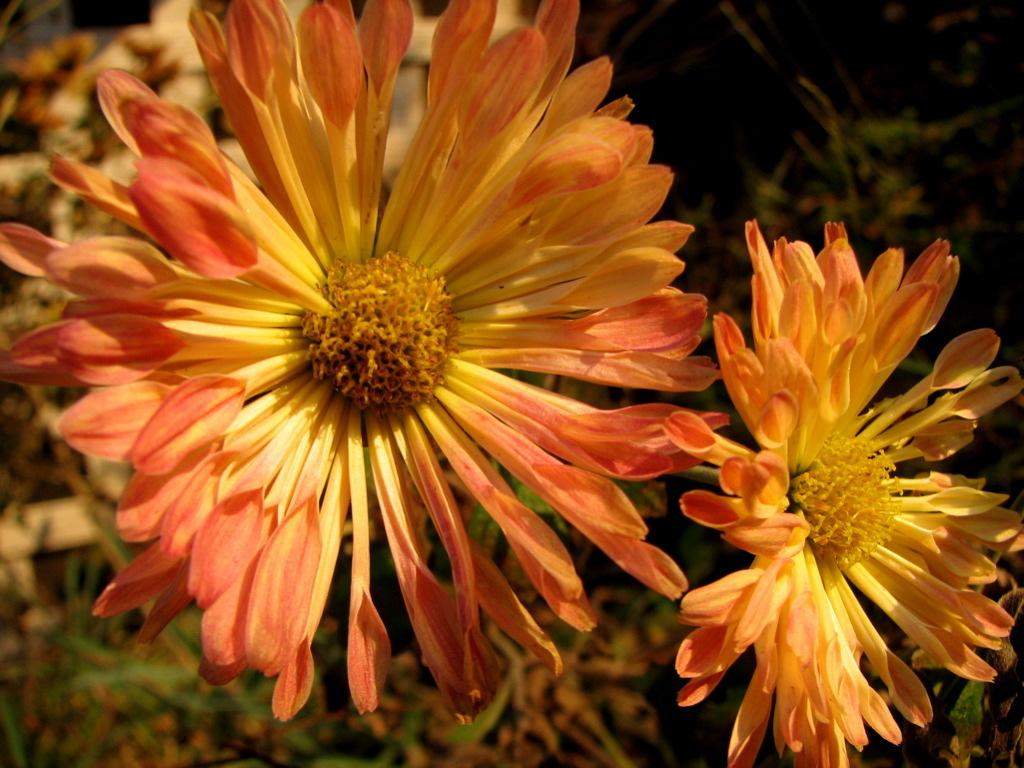What is present in the image? There are flowers in the image. Can you describe the background of the image? The background of the image is blurred. What is the opinion of the servant about the apparel in the image? There is no servant or apparel present in the image, so it is not possible to answer that question. 